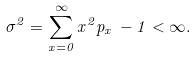Convert formula to latex. <formula><loc_0><loc_0><loc_500><loc_500>\sigma ^ { 2 } = \sum _ { x = 0 } ^ { \infty } x ^ { 2 } p _ { x } \, - 1 < \infty .</formula> 